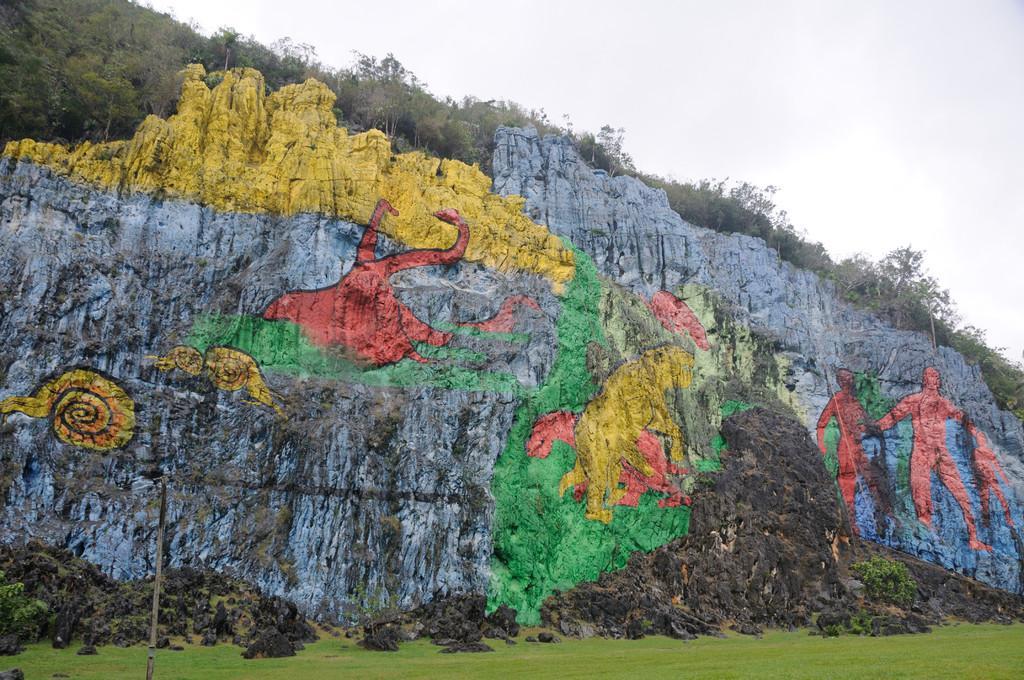Can you describe this image briefly? In the center of the image we can see a mountain with painting on it. There are trees. At the bottom of the image there is grass. At the top of the image there is sky. 